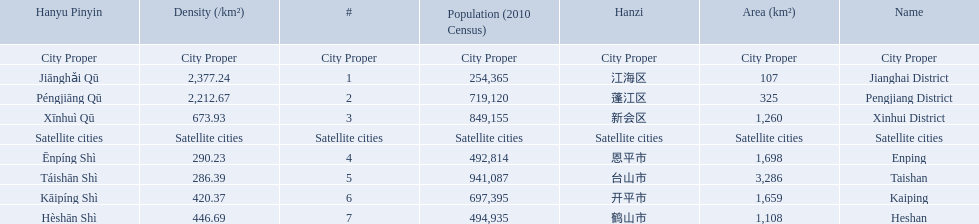What are all of the city proper district names? Jianghai District, Pengjiang District, Xinhui District. Of those districts, what are is the value for their area (km2)? 107, 325, 1,260. Of those area values, which district does the smallest value belong to? Jianghai District. 